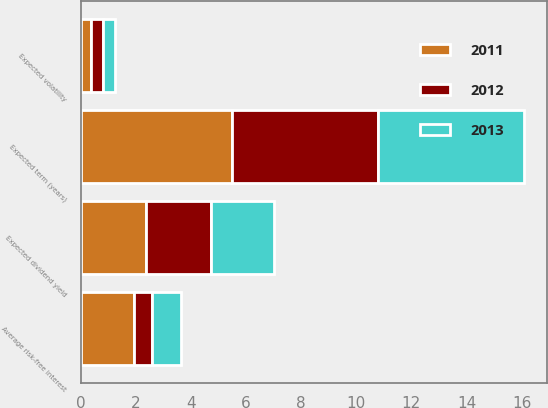Convert chart to OTSL. <chart><loc_0><loc_0><loc_500><loc_500><stacked_bar_chart><ecel><fcel>Average risk-free interest<fcel>Expected dividend yield<fcel>Expected volatility<fcel>Expected term (years)<nl><fcel>2012<fcel>0.66<fcel>2.35<fcel>0.43<fcel>5.3<nl><fcel>2013<fcel>1.06<fcel>2.29<fcel>0.43<fcel>5.3<nl><fcel>2011<fcel>1.94<fcel>2.37<fcel>0.39<fcel>5.5<nl></chart> 